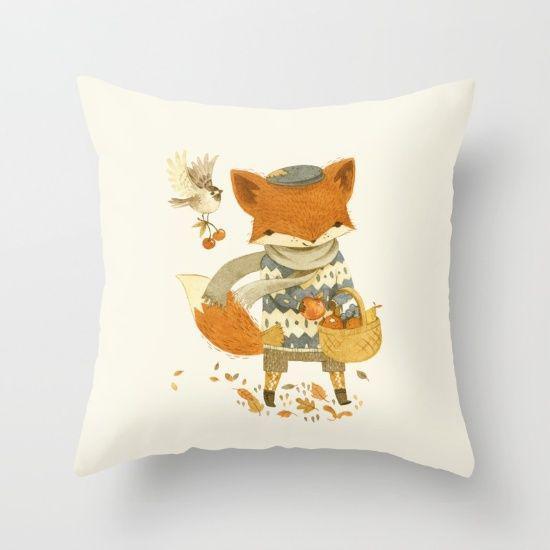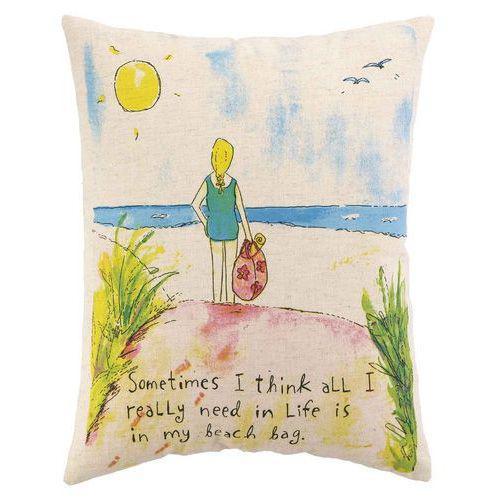The first image is the image on the left, the second image is the image on the right. Evaluate the accuracy of this statement regarding the images: "One image features one square pillow decorated with flowers, and the other image features at least one fabric item decorated with sprigs of lavender.". Is it true? Answer yes or no. No. The first image is the image on the left, the second image is the image on the right. Given the left and right images, does the statement "At least one of the items contains a image of a lavender plant." hold true? Answer yes or no. No. 